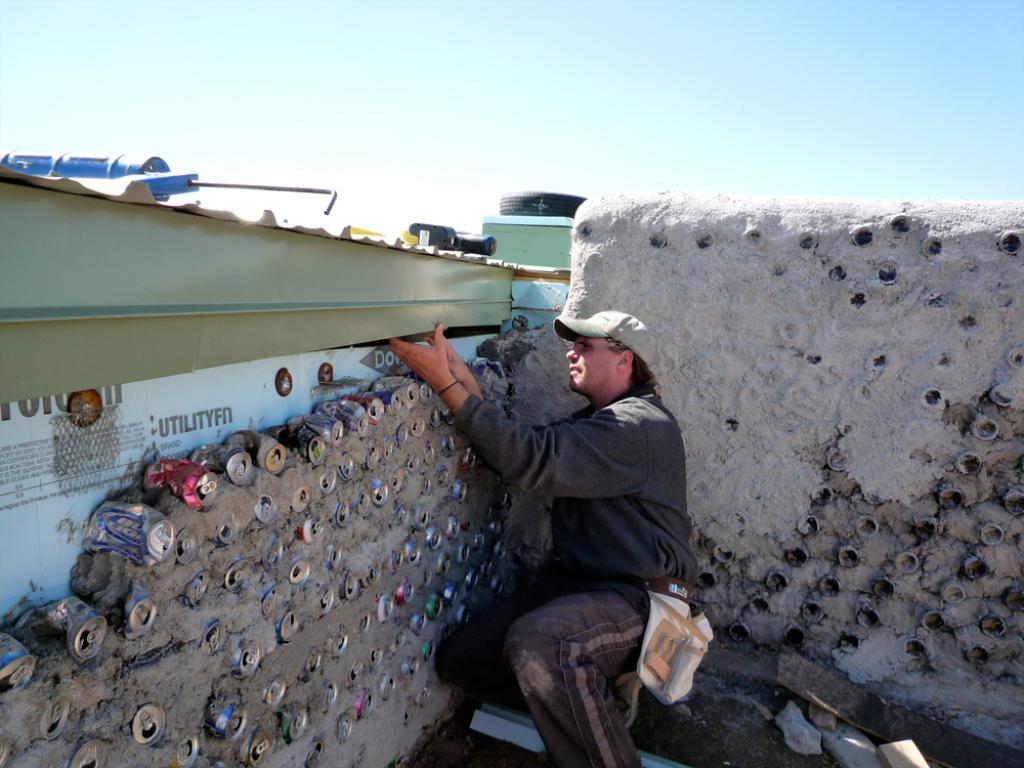What word is displayed on the white wall?
Your answer should be compact. Utilityfn. 